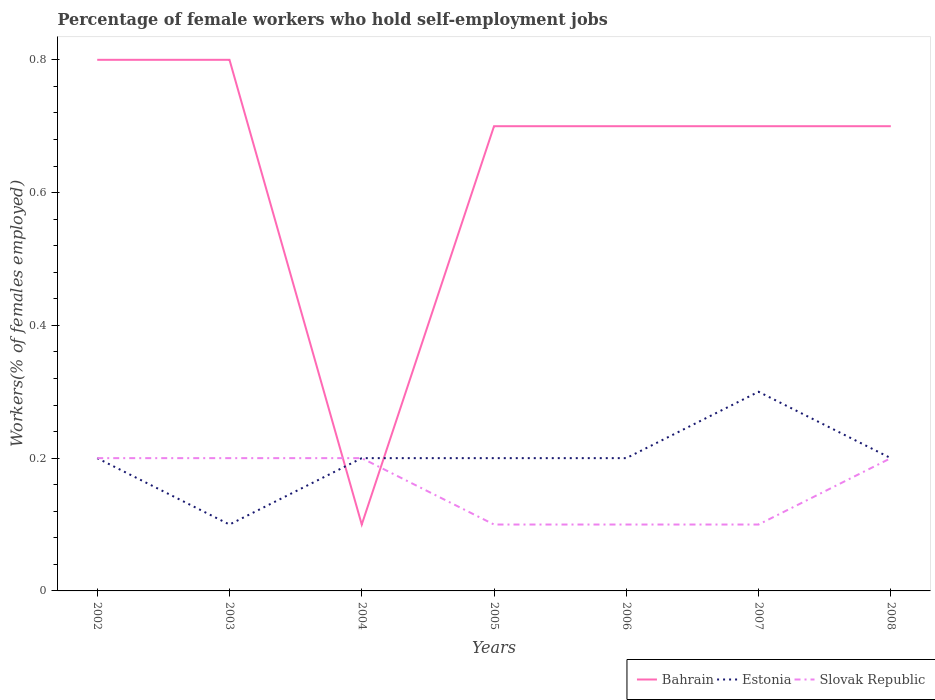How many different coloured lines are there?
Your answer should be very brief. 3. Is the number of lines equal to the number of legend labels?
Make the answer very short. Yes. Across all years, what is the maximum percentage of self-employed female workers in Slovak Republic?
Your response must be concise. 0.1. What is the total percentage of self-employed female workers in Slovak Republic in the graph?
Your answer should be compact. 0.1. What is the difference between the highest and the second highest percentage of self-employed female workers in Estonia?
Provide a succinct answer. 0.2. What is the difference between the highest and the lowest percentage of self-employed female workers in Slovak Republic?
Provide a short and direct response. 4. Is the percentage of self-employed female workers in Slovak Republic strictly greater than the percentage of self-employed female workers in Bahrain over the years?
Your answer should be compact. No. How many lines are there?
Ensure brevity in your answer.  3. How many years are there in the graph?
Offer a very short reply. 7. Are the values on the major ticks of Y-axis written in scientific E-notation?
Provide a short and direct response. No. How are the legend labels stacked?
Your response must be concise. Horizontal. What is the title of the graph?
Keep it short and to the point. Percentage of female workers who hold self-employment jobs. Does "Sint Maarten (Dutch part)" appear as one of the legend labels in the graph?
Provide a short and direct response. No. What is the label or title of the Y-axis?
Provide a succinct answer. Workers(% of females employed). What is the Workers(% of females employed) of Bahrain in 2002?
Your answer should be very brief. 0.8. What is the Workers(% of females employed) in Estonia in 2002?
Offer a terse response. 0.2. What is the Workers(% of females employed) in Slovak Republic in 2002?
Your answer should be compact. 0.2. What is the Workers(% of females employed) of Bahrain in 2003?
Your answer should be very brief. 0.8. What is the Workers(% of females employed) of Estonia in 2003?
Provide a short and direct response. 0.1. What is the Workers(% of females employed) in Slovak Republic in 2003?
Your answer should be compact. 0.2. What is the Workers(% of females employed) of Bahrain in 2004?
Keep it short and to the point. 0.1. What is the Workers(% of females employed) in Estonia in 2004?
Provide a short and direct response. 0.2. What is the Workers(% of females employed) of Slovak Republic in 2004?
Your answer should be very brief. 0.2. What is the Workers(% of females employed) of Bahrain in 2005?
Offer a very short reply. 0.7. What is the Workers(% of females employed) of Estonia in 2005?
Provide a short and direct response. 0.2. What is the Workers(% of females employed) of Slovak Republic in 2005?
Your answer should be compact. 0.1. What is the Workers(% of females employed) in Bahrain in 2006?
Your response must be concise. 0.7. What is the Workers(% of females employed) in Estonia in 2006?
Provide a short and direct response. 0.2. What is the Workers(% of females employed) in Slovak Republic in 2006?
Your response must be concise. 0.1. What is the Workers(% of females employed) of Bahrain in 2007?
Offer a very short reply. 0.7. What is the Workers(% of females employed) in Estonia in 2007?
Your answer should be compact. 0.3. What is the Workers(% of females employed) of Slovak Republic in 2007?
Ensure brevity in your answer.  0.1. What is the Workers(% of females employed) in Bahrain in 2008?
Make the answer very short. 0.7. What is the Workers(% of females employed) in Estonia in 2008?
Your answer should be compact. 0.2. What is the Workers(% of females employed) of Slovak Republic in 2008?
Provide a succinct answer. 0.2. Across all years, what is the maximum Workers(% of females employed) of Bahrain?
Your answer should be very brief. 0.8. Across all years, what is the maximum Workers(% of females employed) in Estonia?
Offer a terse response. 0.3. Across all years, what is the maximum Workers(% of females employed) in Slovak Republic?
Give a very brief answer. 0.2. Across all years, what is the minimum Workers(% of females employed) of Bahrain?
Keep it short and to the point. 0.1. Across all years, what is the minimum Workers(% of females employed) of Estonia?
Ensure brevity in your answer.  0.1. Across all years, what is the minimum Workers(% of females employed) in Slovak Republic?
Your answer should be very brief. 0.1. What is the total Workers(% of females employed) in Slovak Republic in the graph?
Provide a short and direct response. 1.1. What is the difference between the Workers(% of females employed) in Estonia in 2002 and that in 2003?
Keep it short and to the point. 0.1. What is the difference between the Workers(% of females employed) of Bahrain in 2002 and that in 2005?
Offer a terse response. 0.1. What is the difference between the Workers(% of females employed) of Slovak Republic in 2002 and that in 2005?
Keep it short and to the point. 0.1. What is the difference between the Workers(% of females employed) of Estonia in 2002 and that in 2006?
Ensure brevity in your answer.  0. What is the difference between the Workers(% of females employed) of Slovak Republic in 2002 and that in 2006?
Keep it short and to the point. 0.1. What is the difference between the Workers(% of females employed) of Estonia in 2002 and that in 2007?
Give a very brief answer. -0.1. What is the difference between the Workers(% of females employed) in Slovak Republic in 2002 and that in 2007?
Offer a terse response. 0.1. What is the difference between the Workers(% of females employed) in Bahrain in 2003 and that in 2005?
Ensure brevity in your answer.  0.1. What is the difference between the Workers(% of females employed) of Estonia in 2003 and that in 2006?
Provide a succinct answer. -0.1. What is the difference between the Workers(% of females employed) of Bahrain in 2003 and that in 2007?
Keep it short and to the point. 0.1. What is the difference between the Workers(% of females employed) of Slovak Republic in 2003 and that in 2007?
Provide a short and direct response. 0.1. What is the difference between the Workers(% of females employed) in Slovak Republic in 2003 and that in 2008?
Provide a short and direct response. 0. What is the difference between the Workers(% of females employed) of Bahrain in 2004 and that in 2005?
Your response must be concise. -0.6. What is the difference between the Workers(% of females employed) of Estonia in 2004 and that in 2005?
Provide a short and direct response. 0. What is the difference between the Workers(% of females employed) in Slovak Republic in 2004 and that in 2005?
Give a very brief answer. 0.1. What is the difference between the Workers(% of females employed) of Bahrain in 2004 and that in 2006?
Offer a terse response. -0.6. What is the difference between the Workers(% of females employed) in Estonia in 2004 and that in 2006?
Give a very brief answer. 0. What is the difference between the Workers(% of females employed) of Estonia in 2004 and that in 2007?
Your response must be concise. -0.1. What is the difference between the Workers(% of females employed) of Bahrain in 2004 and that in 2008?
Provide a succinct answer. -0.6. What is the difference between the Workers(% of females employed) of Estonia in 2004 and that in 2008?
Offer a terse response. 0. What is the difference between the Workers(% of females employed) of Slovak Republic in 2005 and that in 2006?
Your answer should be compact. 0. What is the difference between the Workers(% of females employed) in Estonia in 2005 and that in 2007?
Ensure brevity in your answer.  -0.1. What is the difference between the Workers(% of females employed) in Estonia in 2005 and that in 2008?
Your response must be concise. 0. What is the difference between the Workers(% of females employed) in Slovak Republic in 2005 and that in 2008?
Your answer should be very brief. -0.1. What is the difference between the Workers(% of females employed) of Bahrain in 2006 and that in 2007?
Ensure brevity in your answer.  0. What is the difference between the Workers(% of females employed) of Bahrain in 2006 and that in 2008?
Make the answer very short. 0. What is the difference between the Workers(% of females employed) of Estonia in 2006 and that in 2008?
Your response must be concise. 0. What is the difference between the Workers(% of females employed) of Estonia in 2007 and that in 2008?
Keep it short and to the point. 0.1. What is the difference between the Workers(% of females employed) in Bahrain in 2002 and the Workers(% of females employed) in Estonia in 2003?
Your answer should be compact. 0.7. What is the difference between the Workers(% of females employed) in Estonia in 2002 and the Workers(% of females employed) in Slovak Republic in 2003?
Your answer should be very brief. 0. What is the difference between the Workers(% of females employed) in Bahrain in 2002 and the Workers(% of females employed) in Estonia in 2004?
Offer a very short reply. 0.6. What is the difference between the Workers(% of females employed) in Estonia in 2002 and the Workers(% of females employed) in Slovak Republic in 2004?
Your response must be concise. 0. What is the difference between the Workers(% of females employed) in Bahrain in 2002 and the Workers(% of females employed) in Slovak Republic in 2005?
Make the answer very short. 0.7. What is the difference between the Workers(% of females employed) in Estonia in 2002 and the Workers(% of females employed) in Slovak Republic in 2005?
Your response must be concise. 0.1. What is the difference between the Workers(% of females employed) in Bahrain in 2002 and the Workers(% of females employed) in Estonia in 2006?
Ensure brevity in your answer.  0.6. What is the difference between the Workers(% of females employed) in Estonia in 2002 and the Workers(% of females employed) in Slovak Republic in 2006?
Keep it short and to the point. 0.1. What is the difference between the Workers(% of females employed) of Bahrain in 2002 and the Workers(% of females employed) of Estonia in 2007?
Your answer should be compact. 0.5. What is the difference between the Workers(% of females employed) in Bahrain in 2002 and the Workers(% of females employed) in Slovak Republic in 2007?
Your response must be concise. 0.7. What is the difference between the Workers(% of females employed) of Estonia in 2002 and the Workers(% of females employed) of Slovak Republic in 2007?
Keep it short and to the point. 0.1. What is the difference between the Workers(% of females employed) in Bahrain in 2002 and the Workers(% of females employed) in Slovak Republic in 2008?
Offer a terse response. 0.6. What is the difference between the Workers(% of females employed) of Estonia in 2002 and the Workers(% of females employed) of Slovak Republic in 2008?
Your answer should be compact. 0. What is the difference between the Workers(% of females employed) in Bahrain in 2003 and the Workers(% of females employed) in Estonia in 2004?
Offer a very short reply. 0.6. What is the difference between the Workers(% of females employed) of Estonia in 2003 and the Workers(% of females employed) of Slovak Republic in 2004?
Your answer should be very brief. -0.1. What is the difference between the Workers(% of females employed) of Bahrain in 2003 and the Workers(% of females employed) of Estonia in 2005?
Give a very brief answer. 0.6. What is the difference between the Workers(% of females employed) of Bahrain in 2003 and the Workers(% of females employed) of Estonia in 2006?
Your response must be concise. 0.6. What is the difference between the Workers(% of females employed) of Estonia in 2003 and the Workers(% of females employed) of Slovak Republic in 2007?
Your answer should be very brief. 0. What is the difference between the Workers(% of females employed) of Bahrain in 2004 and the Workers(% of females employed) of Estonia in 2005?
Ensure brevity in your answer.  -0.1. What is the difference between the Workers(% of females employed) of Bahrain in 2004 and the Workers(% of females employed) of Slovak Republic in 2005?
Make the answer very short. 0. What is the difference between the Workers(% of females employed) in Estonia in 2004 and the Workers(% of females employed) in Slovak Republic in 2006?
Offer a terse response. 0.1. What is the difference between the Workers(% of females employed) of Bahrain in 2004 and the Workers(% of females employed) of Estonia in 2007?
Offer a very short reply. -0.2. What is the difference between the Workers(% of females employed) in Bahrain in 2004 and the Workers(% of females employed) in Slovak Republic in 2007?
Provide a short and direct response. 0. What is the difference between the Workers(% of females employed) in Estonia in 2004 and the Workers(% of females employed) in Slovak Republic in 2007?
Offer a very short reply. 0.1. What is the difference between the Workers(% of females employed) in Bahrain in 2004 and the Workers(% of females employed) in Slovak Republic in 2008?
Provide a short and direct response. -0.1. What is the difference between the Workers(% of females employed) of Bahrain in 2005 and the Workers(% of females employed) of Slovak Republic in 2006?
Provide a succinct answer. 0.6. What is the difference between the Workers(% of females employed) in Estonia in 2005 and the Workers(% of females employed) in Slovak Republic in 2006?
Ensure brevity in your answer.  0.1. What is the difference between the Workers(% of females employed) in Bahrain in 2005 and the Workers(% of females employed) in Slovak Republic in 2007?
Your answer should be very brief. 0.6. What is the difference between the Workers(% of females employed) of Estonia in 2005 and the Workers(% of females employed) of Slovak Republic in 2007?
Keep it short and to the point. 0.1. What is the difference between the Workers(% of females employed) of Bahrain in 2005 and the Workers(% of females employed) of Estonia in 2008?
Your response must be concise. 0.5. What is the difference between the Workers(% of females employed) of Bahrain in 2005 and the Workers(% of females employed) of Slovak Republic in 2008?
Your answer should be compact. 0.5. What is the difference between the Workers(% of females employed) in Bahrain in 2006 and the Workers(% of females employed) in Estonia in 2007?
Provide a succinct answer. 0.4. What is the difference between the Workers(% of females employed) in Bahrain in 2006 and the Workers(% of females employed) in Slovak Republic in 2007?
Give a very brief answer. 0.6. What is the difference between the Workers(% of females employed) of Bahrain in 2006 and the Workers(% of females employed) of Estonia in 2008?
Your answer should be very brief. 0.5. What is the difference between the Workers(% of females employed) of Estonia in 2006 and the Workers(% of females employed) of Slovak Republic in 2008?
Offer a terse response. 0. What is the difference between the Workers(% of females employed) of Bahrain in 2007 and the Workers(% of females employed) of Estonia in 2008?
Provide a short and direct response. 0.5. What is the difference between the Workers(% of females employed) of Bahrain in 2007 and the Workers(% of females employed) of Slovak Republic in 2008?
Ensure brevity in your answer.  0.5. What is the average Workers(% of females employed) of Bahrain per year?
Offer a very short reply. 0.64. What is the average Workers(% of females employed) in Slovak Republic per year?
Provide a short and direct response. 0.16. In the year 2002, what is the difference between the Workers(% of females employed) in Bahrain and Workers(% of females employed) in Estonia?
Provide a succinct answer. 0.6. In the year 2002, what is the difference between the Workers(% of females employed) of Bahrain and Workers(% of females employed) of Slovak Republic?
Make the answer very short. 0.6. In the year 2002, what is the difference between the Workers(% of females employed) in Estonia and Workers(% of females employed) in Slovak Republic?
Make the answer very short. 0. In the year 2003, what is the difference between the Workers(% of females employed) of Bahrain and Workers(% of females employed) of Slovak Republic?
Your answer should be compact. 0.6. In the year 2004, what is the difference between the Workers(% of females employed) in Bahrain and Workers(% of females employed) in Estonia?
Make the answer very short. -0.1. In the year 2004, what is the difference between the Workers(% of females employed) of Estonia and Workers(% of females employed) of Slovak Republic?
Offer a terse response. 0. In the year 2005, what is the difference between the Workers(% of females employed) of Estonia and Workers(% of females employed) of Slovak Republic?
Provide a succinct answer. 0.1. In the year 2006, what is the difference between the Workers(% of females employed) in Bahrain and Workers(% of females employed) in Estonia?
Offer a very short reply. 0.5. In the year 2006, what is the difference between the Workers(% of females employed) of Bahrain and Workers(% of females employed) of Slovak Republic?
Give a very brief answer. 0.6. In the year 2006, what is the difference between the Workers(% of females employed) in Estonia and Workers(% of females employed) in Slovak Republic?
Your answer should be compact. 0.1. In the year 2007, what is the difference between the Workers(% of females employed) of Bahrain and Workers(% of females employed) of Estonia?
Your answer should be very brief. 0.4. In the year 2007, what is the difference between the Workers(% of females employed) of Estonia and Workers(% of females employed) of Slovak Republic?
Your answer should be very brief. 0.2. What is the ratio of the Workers(% of females employed) of Slovak Republic in 2002 to that in 2004?
Offer a terse response. 1. What is the ratio of the Workers(% of females employed) of Estonia in 2002 to that in 2005?
Keep it short and to the point. 1. What is the ratio of the Workers(% of females employed) in Slovak Republic in 2002 to that in 2005?
Offer a terse response. 2. What is the ratio of the Workers(% of females employed) in Estonia in 2002 to that in 2006?
Offer a very short reply. 1. What is the ratio of the Workers(% of females employed) of Slovak Republic in 2002 to that in 2006?
Keep it short and to the point. 2. What is the ratio of the Workers(% of females employed) of Bahrain in 2002 to that in 2007?
Provide a short and direct response. 1.14. What is the ratio of the Workers(% of females employed) of Slovak Republic in 2002 to that in 2007?
Ensure brevity in your answer.  2. What is the ratio of the Workers(% of females employed) in Bahrain in 2002 to that in 2008?
Make the answer very short. 1.14. What is the ratio of the Workers(% of females employed) in Estonia in 2002 to that in 2008?
Provide a short and direct response. 1. What is the ratio of the Workers(% of females employed) of Estonia in 2003 to that in 2004?
Keep it short and to the point. 0.5. What is the ratio of the Workers(% of females employed) in Slovak Republic in 2003 to that in 2004?
Provide a short and direct response. 1. What is the ratio of the Workers(% of females employed) of Estonia in 2003 to that in 2005?
Give a very brief answer. 0.5. What is the ratio of the Workers(% of females employed) of Estonia in 2003 to that in 2006?
Your response must be concise. 0.5. What is the ratio of the Workers(% of females employed) in Slovak Republic in 2003 to that in 2006?
Your response must be concise. 2. What is the ratio of the Workers(% of females employed) in Bahrain in 2003 to that in 2007?
Provide a succinct answer. 1.14. What is the ratio of the Workers(% of females employed) of Bahrain in 2004 to that in 2005?
Offer a terse response. 0.14. What is the ratio of the Workers(% of females employed) in Slovak Republic in 2004 to that in 2005?
Offer a terse response. 2. What is the ratio of the Workers(% of females employed) in Bahrain in 2004 to that in 2006?
Make the answer very short. 0.14. What is the ratio of the Workers(% of females employed) of Estonia in 2004 to that in 2006?
Keep it short and to the point. 1. What is the ratio of the Workers(% of females employed) of Slovak Republic in 2004 to that in 2006?
Your answer should be very brief. 2. What is the ratio of the Workers(% of females employed) of Bahrain in 2004 to that in 2007?
Your answer should be compact. 0.14. What is the ratio of the Workers(% of females employed) in Estonia in 2004 to that in 2007?
Your response must be concise. 0.67. What is the ratio of the Workers(% of females employed) in Bahrain in 2004 to that in 2008?
Ensure brevity in your answer.  0.14. What is the ratio of the Workers(% of females employed) in Estonia in 2004 to that in 2008?
Ensure brevity in your answer.  1. What is the ratio of the Workers(% of females employed) of Slovak Republic in 2004 to that in 2008?
Offer a terse response. 1. What is the ratio of the Workers(% of females employed) of Bahrain in 2005 to that in 2006?
Offer a very short reply. 1. What is the ratio of the Workers(% of females employed) of Slovak Republic in 2005 to that in 2006?
Your answer should be very brief. 1. What is the ratio of the Workers(% of females employed) in Estonia in 2005 to that in 2007?
Ensure brevity in your answer.  0.67. What is the ratio of the Workers(% of females employed) in Slovak Republic in 2005 to that in 2007?
Ensure brevity in your answer.  1. What is the ratio of the Workers(% of females employed) of Bahrain in 2005 to that in 2008?
Offer a terse response. 1. What is the ratio of the Workers(% of females employed) of Estonia in 2006 to that in 2007?
Make the answer very short. 0.67. What is the ratio of the Workers(% of females employed) of Bahrain in 2007 to that in 2008?
Offer a very short reply. 1. What is the ratio of the Workers(% of females employed) in Slovak Republic in 2007 to that in 2008?
Ensure brevity in your answer.  0.5. What is the difference between the highest and the second highest Workers(% of females employed) in Bahrain?
Offer a terse response. 0. What is the difference between the highest and the lowest Workers(% of females employed) of Bahrain?
Your answer should be compact. 0.7. What is the difference between the highest and the lowest Workers(% of females employed) of Estonia?
Provide a succinct answer. 0.2. What is the difference between the highest and the lowest Workers(% of females employed) in Slovak Republic?
Make the answer very short. 0.1. 